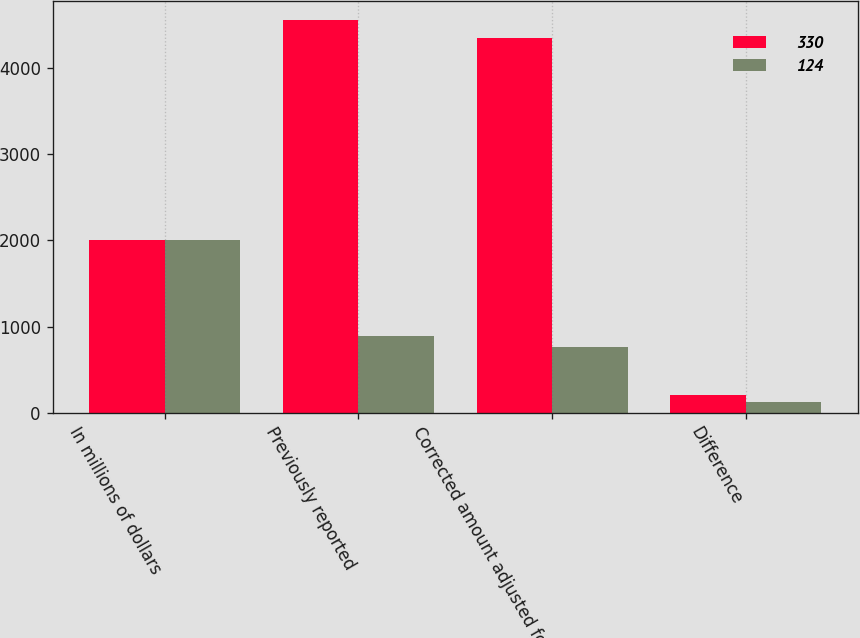Convert chart. <chart><loc_0><loc_0><loc_500><loc_500><stacked_bar_chart><ecel><fcel>In millions of dollars<fcel>Previously reported<fcel>Corrected amount adjusted for<fcel>Difference<nl><fcel>330<fcel>2008<fcel>4558<fcel>4352<fcel>206<nl><fcel>124<fcel>2007<fcel>888<fcel>764<fcel>124<nl></chart> 